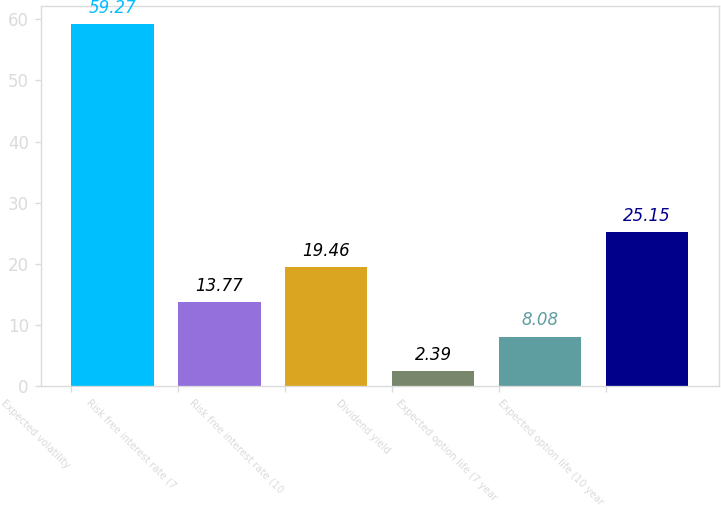Convert chart to OTSL. <chart><loc_0><loc_0><loc_500><loc_500><bar_chart><fcel>Expected volatility<fcel>Risk free interest rate (7<fcel>Risk free interest rate (10<fcel>Dividend yield<fcel>Expected option life (7 year<fcel>Expected option life (10 year<nl><fcel>59.27<fcel>13.77<fcel>19.46<fcel>2.39<fcel>8.08<fcel>25.15<nl></chart> 